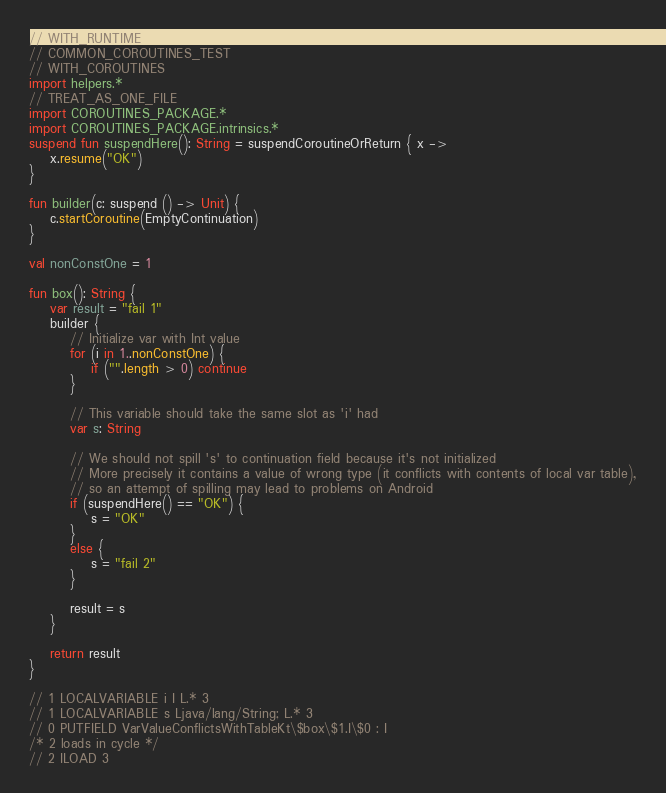Convert code to text. <code><loc_0><loc_0><loc_500><loc_500><_Kotlin_>// WITH_RUNTIME
// COMMON_COROUTINES_TEST
// WITH_COROUTINES
import helpers.*
// TREAT_AS_ONE_FILE
import COROUTINES_PACKAGE.*
import COROUTINES_PACKAGE.intrinsics.*
suspend fun suspendHere(): String = suspendCoroutineOrReturn { x ->
    x.resume("OK")
}

fun builder(c: suspend () -> Unit) {
    c.startCoroutine(EmptyContinuation)
}

val nonConstOne = 1

fun box(): String {
    var result = "fail 1"
    builder {
        // Initialize var with Int value
        for (i in 1..nonConstOne) {
            if ("".length > 0) continue
        }

        // This variable should take the same slot as 'i' had
        var s: String

        // We should not spill 's' to continuation field because it's not initialized
        // More precisely it contains a value of wrong type (it conflicts with contents of local var table),
        // so an attempt of spilling may lead to problems on Android
        if (suspendHere() == "OK") {
            s = "OK"
        }
        else {
            s = "fail 2"
        }

        result = s
    }

    return result
}

// 1 LOCALVARIABLE i I L.* 3
// 1 LOCALVARIABLE s Ljava/lang/String; L.* 3
// 0 PUTFIELD VarValueConflictsWithTableKt\$box\$1.I\$0 : I
/* 2 loads in cycle */
// 2 ILOAD 3</code> 